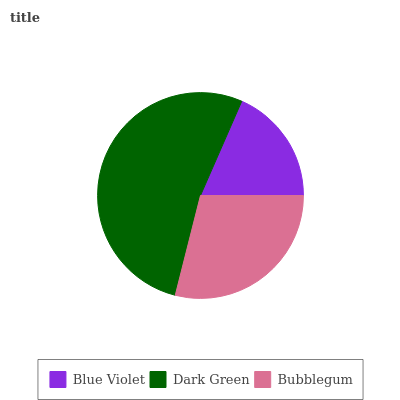Is Blue Violet the minimum?
Answer yes or no. Yes. Is Dark Green the maximum?
Answer yes or no. Yes. Is Bubblegum the minimum?
Answer yes or no. No. Is Bubblegum the maximum?
Answer yes or no. No. Is Dark Green greater than Bubblegum?
Answer yes or no. Yes. Is Bubblegum less than Dark Green?
Answer yes or no. Yes. Is Bubblegum greater than Dark Green?
Answer yes or no. No. Is Dark Green less than Bubblegum?
Answer yes or no. No. Is Bubblegum the high median?
Answer yes or no. Yes. Is Bubblegum the low median?
Answer yes or no. Yes. Is Dark Green the high median?
Answer yes or no. No. Is Blue Violet the low median?
Answer yes or no. No. 